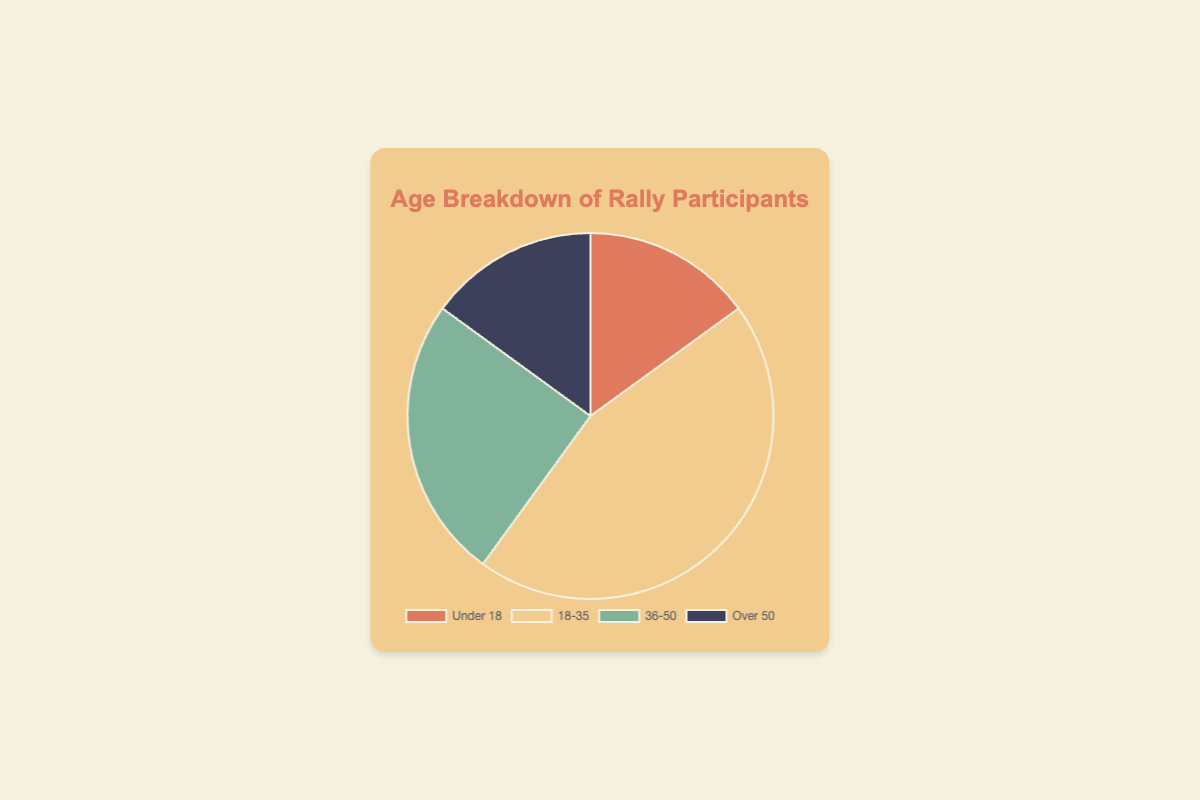What age group has the highest proportion of rally participants? The pie chart shows that the 18-35 age group has the largest slice. Therefore, the 18-35 age group has the highest proportion of participants.
Answer: 18-35 Which two age groups have equal proportions of participants? The pie chart shows that the Under 18 and Over 50 age groups have equal-sized slices. Therefore, these two groups have equal proportions of participants.
Answer: Under 18 and Over 50 How much more is the proportion of participants aged 18-35 compared to those Over 50? From the pie chart, the 18-35 group constitutes 45% and the Over 50 group 15%. 45% - 15% = 30%. Therefore, the 18-35 age group has 30% more participants than the Over 50 group.
Answer: 30% What is the combined proportion of participants aged Under 18 and Over 50? The pie chart shows that each of these groups has 15% of the participants. Adding them up, 15% + 15% = 30%. Therefore, the combined proportion is 30%.
Answer: 30% What colors represent the Under 18 and 36-50 age groups in the chart? The pie chart uses different colors for each age group. The Under 18 group is represented by red, and the 36-50 group by green.
Answer: Red and Green How does the proportion of the 36-50 age group compare to that of the Under 18 age group? From the pie chart, the 36-50 group has 25% and the Under 18 group 15%. 25% > 15%. Thus, the 36-50 age group has a higher proportion than the Under 18 group.
Answer: Higher What is the sum of the proportions of the age groups Under 18 and 36-50? The pie chart shows that Under 18 has 15% and 36-50 has 25%. Adding them, 15% + 25% = 40%. Therefore, the sum is 40%.
Answer: 40% What is the average proportion of the participants from all age groups? The pie chart data is as follows: 15% (Under 18), 45% (18-35), 25% (36-50), 15% (Over 50). The sum is 15% + 45% + 25% + 15% = 100%. The number of groups is 4. Thus, the average is 100% / 4 = 25%.
Answer: 25% Which age group contributes exactly one-quarter or 25% of the participants? From the pie chart, the 36-50 age group is shown to constitute 25% of the participants. Therefore, the 36-50 age group contributes exactly one-quarter of the participants.
Answer: 36-50 